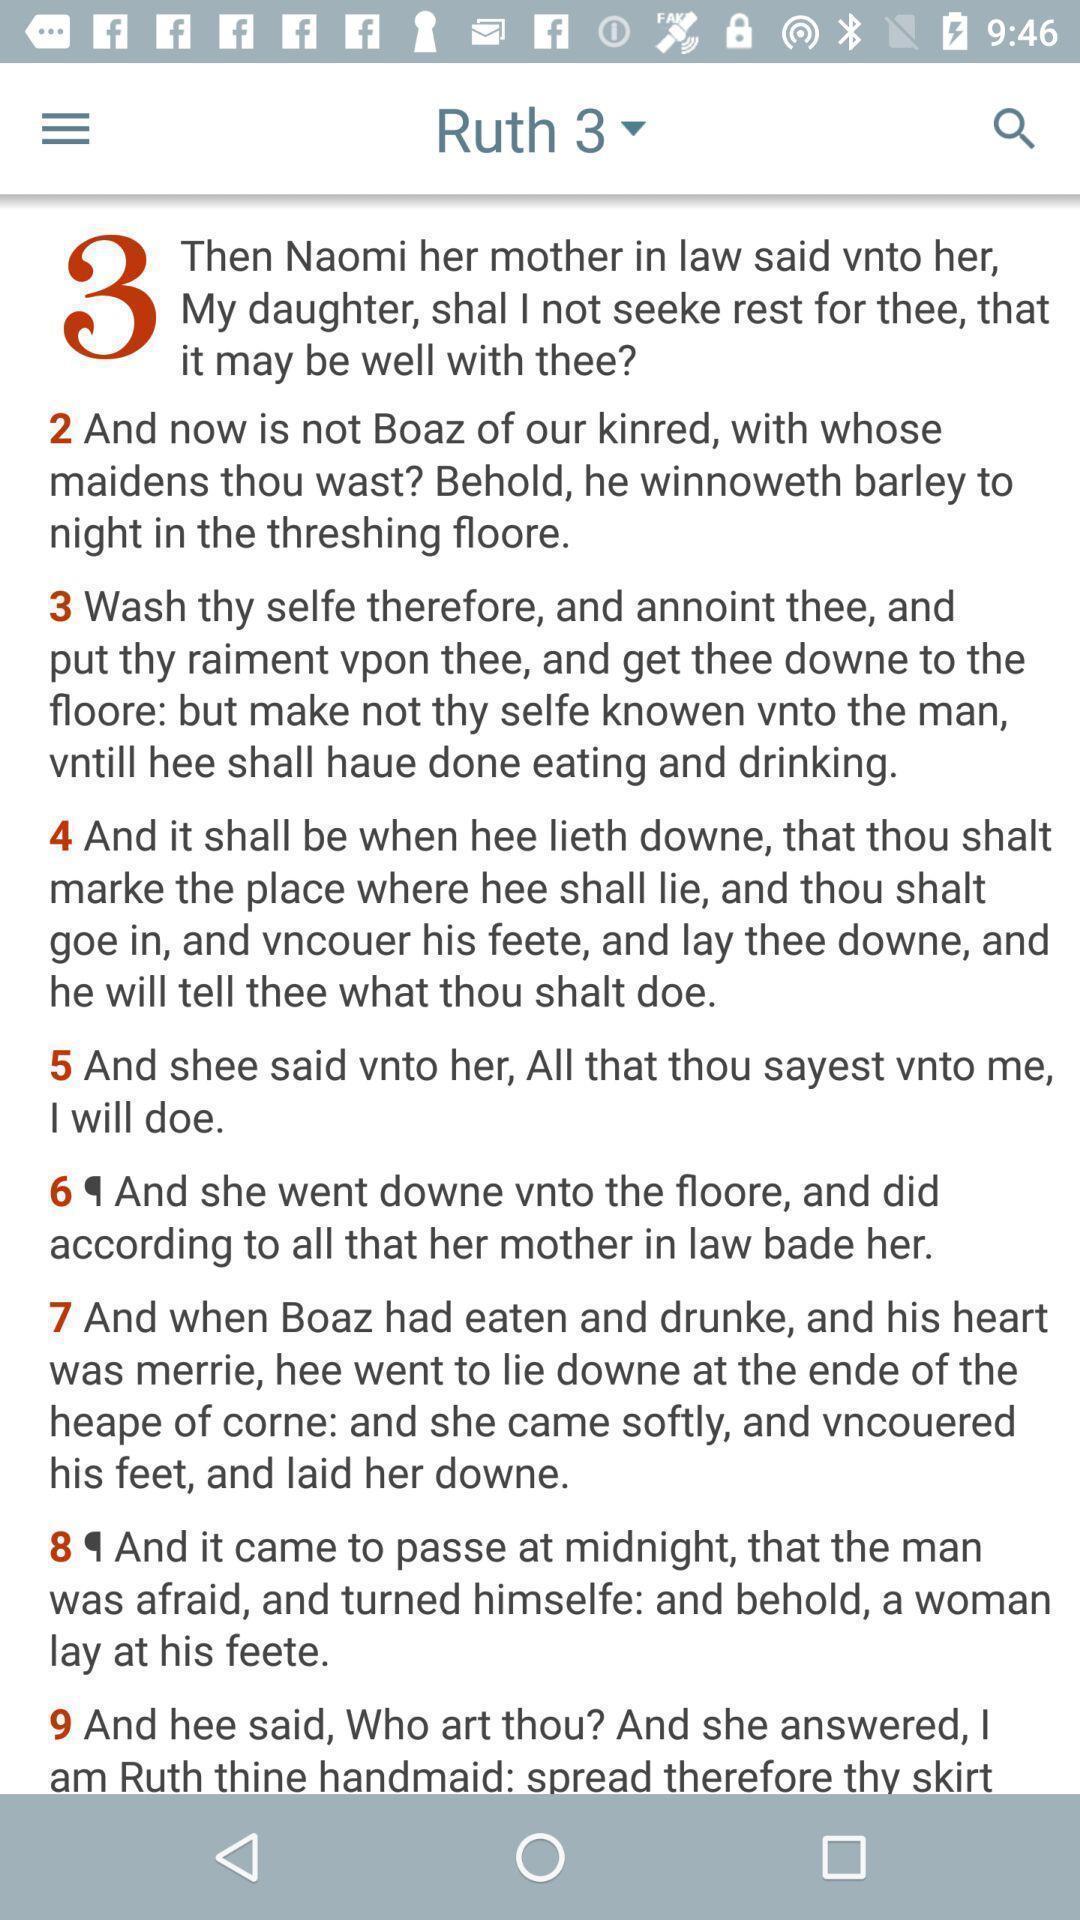What is the overall content of this screenshot? Ruth page of a bible app. 